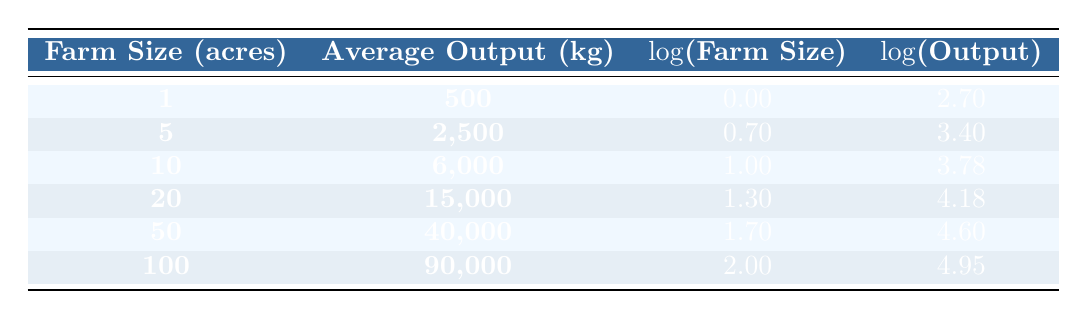What is the average output for a farm size of 5 acres? According to the table, the average output for a farm size of 5 acres is 2,500 kg.
Answer: 2,500 kg What is the logarithm of the farm size for a farm of 100 acres? The table shows that the logarithm of the farm size for 100 acres is 2.00.
Answer: 2.00 Is the average output for a farm size of 1 acre greater than that for a farm size of 10 acres? The average output for a farm size of 1 acre is 500 kg, while for 10 acres it is 6,000 kg. Since 500 is less than 6,000, the statement is false.
Answer: No What is the total average output of the farms with sizes 5 acres and 50 acres combined? The average output for 5 acres is 2,500 kg and for 50 acres is 40,000 kg. Adding these gives 2,500 + 40,000 = 42,500 kg.
Answer: 42,500 kg Does a larger farm size always result in a higher average output? Analyzing the data, we see that as the farm size increases, the average output also increases. Hence, the statement appears to hold true for the given data.
Answer: Yes What is the difference in average output between a 20-acre farm and a 100-acre farm? The average output for a 20-acre farm is 15,000 kg and for a 100-acre farm, it is 90,000 kg. The difference is 90,000 - 15,000 = 75,000 kg.
Answer: 75,000 kg What is the average size (in acres) of the farms listed in the table? The farm sizes listed are 1, 5, 10, 20, 50, and 100 acres. To find the average, we sum these values: 1 + 5 + 10 + 20 + 50 + 100 = 186 acres, and divide by the number of farms (6) which gives 186 / 6 = 31 acres.
Answer: 31 acres Which farm size has the highest average output? Looking at the table, the farm size of 100 acres has the highest average output, which is 90,000 kg.
Answer: 100 acres What is the log of the average output for a farm of 50 acres? According to the table, the log of the average output for a 50-acre farm is 4.60.
Answer: 4.60 